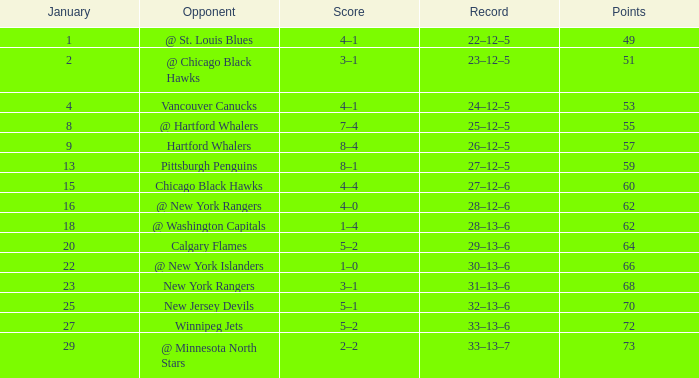Which points exhibit a score of 4-1 with a game that is under 39? None. 